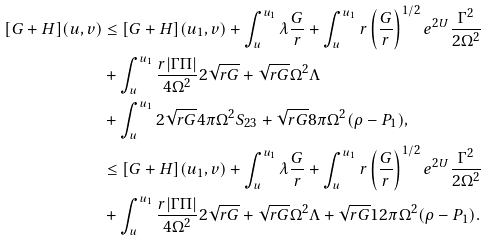<formula> <loc_0><loc_0><loc_500><loc_500>[ G + H ] ( u , v ) & \leq [ G + H ] ( u _ { 1 } , v ) + \int ^ { u _ { 1 } } _ { u } \lambda \frac { G } { r } + \int ^ { u _ { 1 } } _ { u } r \left ( \frac { G } { r } \right ) ^ { 1 / 2 } e ^ { 2 U } \frac { \Gamma ^ { 2 } } { 2 \Omega ^ { 2 } } \\ & + \int ^ { u _ { 1 } } _ { u } \frac { r | \Gamma \Pi | } { 4 \Omega ^ { 2 } } 2 \sqrt { r G } + \sqrt { r G } \Omega ^ { 2 } \Lambda \\ & + \int ^ { u _ { 1 } } _ { u } 2 \sqrt { r G } 4 \pi \Omega ^ { 2 } S _ { 2 3 } + \sqrt { r G } 8 \pi \Omega ^ { 2 } ( \rho - P _ { 1 } ) , \\ & \leq [ G + H ] ( u _ { 1 } , v ) + \int ^ { u _ { 1 } } _ { u } \lambda \frac { G } { r } + \int ^ { u _ { 1 } } _ { u } r \left ( \frac { G } { r } \right ) ^ { 1 / 2 } e ^ { 2 U } \frac { \Gamma ^ { 2 } } { 2 \Omega ^ { 2 } } \\ & + \int ^ { u _ { 1 } } _ { u } \frac { r | \Gamma \Pi | } { 4 \Omega ^ { 2 } } 2 \sqrt { r G } + \sqrt { r G } \Omega ^ { 2 } \Lambda + \sqrt { r G } 1 2 \pi \Omega ^ { 2 } ( \rho - P _ { 1 } ) .</formula> 